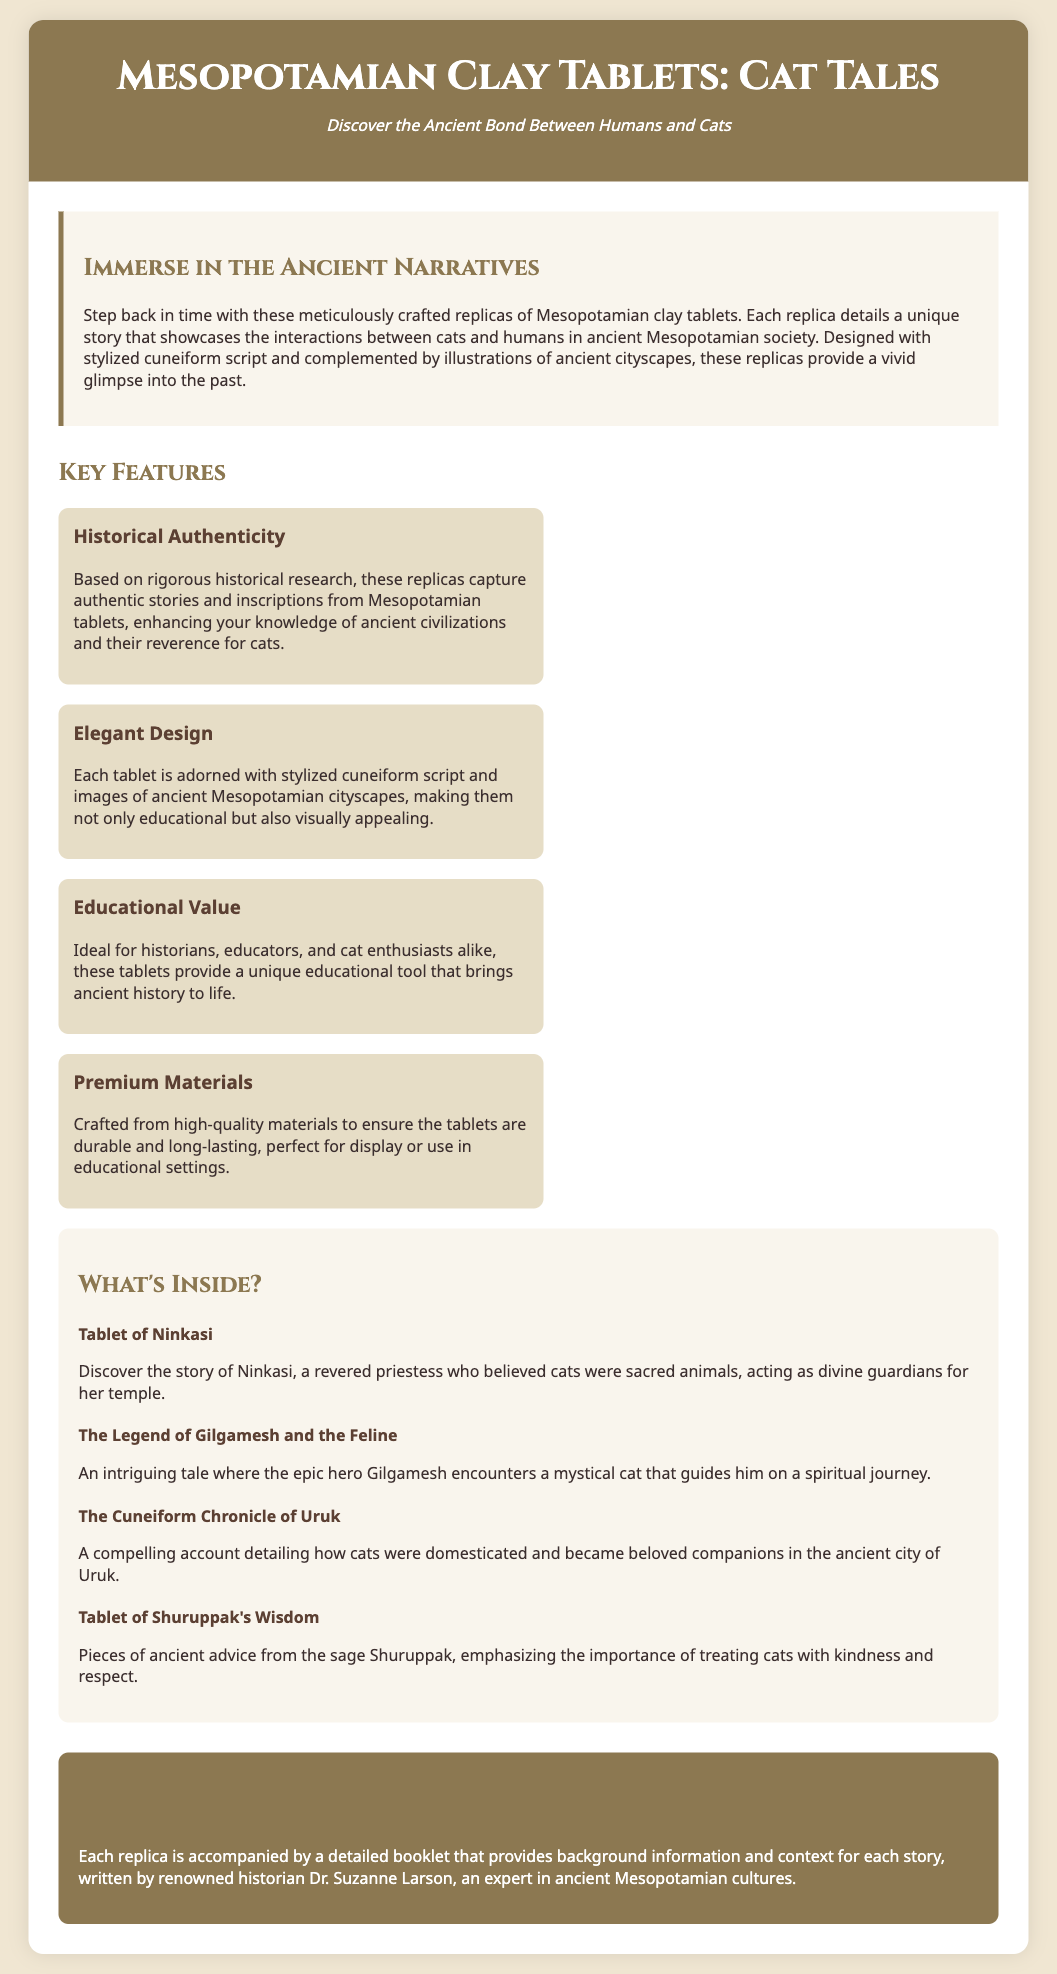What is the title of the product? The title of the product is mentioned at the header of the document, which is "Mesopotamian Clay Tablets: Cat Tales."
Answer: Mesopotamian Clay Tablets: Cat Tales Who is the renowned historian mentioned? The document mentions Dr. Suzanne Larson, who is an expert in ancient Mesopotamian cultures.
Answer: Dr. Suzanne Larson What type of script is used in the design? The document states that the tablets are designed with "stylized cuneiform script."
Answer: stylized cuneiform script How many key features are highlighted? The document outlines four key features provided in separate sections.
Answer: four Which ancient city is specifically mentioned in a tablet? The tablet titled "The Cuneiform Chronicle of Uruk" refers to the ancient city of Uruk.
Answer: Uruk What is the content of the Tablet of Ninkasi? The content describes Ninkasi as a revered priestess who believed cats were sacred animals.
Answer: a revered priestess who believed cats were sacred animals What aesthetic elements complement the tablets? The tablets are complemented by "illustrations of ancient cityscapes," enhancing their visual appeal.
Answer: illustrations of ancient cityscapes What educational purpose do these replicas serve? The replicas are described as providing a unique educational tool for historians and cat enthusiasts, thus enhancing knowledge of ancient history.
Answer: a unique educational tool Which tablet emphasizes kindness toward cats? The "Tablet of Shuruppak's Wisdom" focuses on the importance of treating cats with kindness and respect.
Answer: Tablet of Shuruppak's Wisdom 